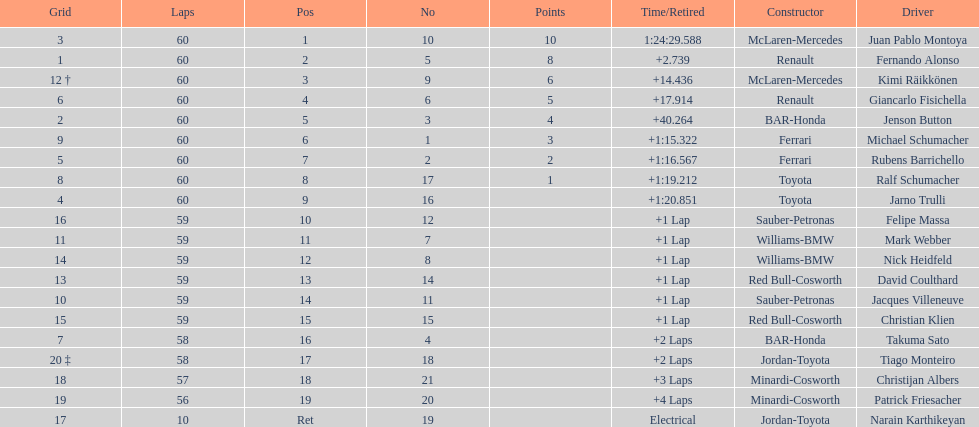Is there a points difference between the 9th position and 19th position on the list? No. 